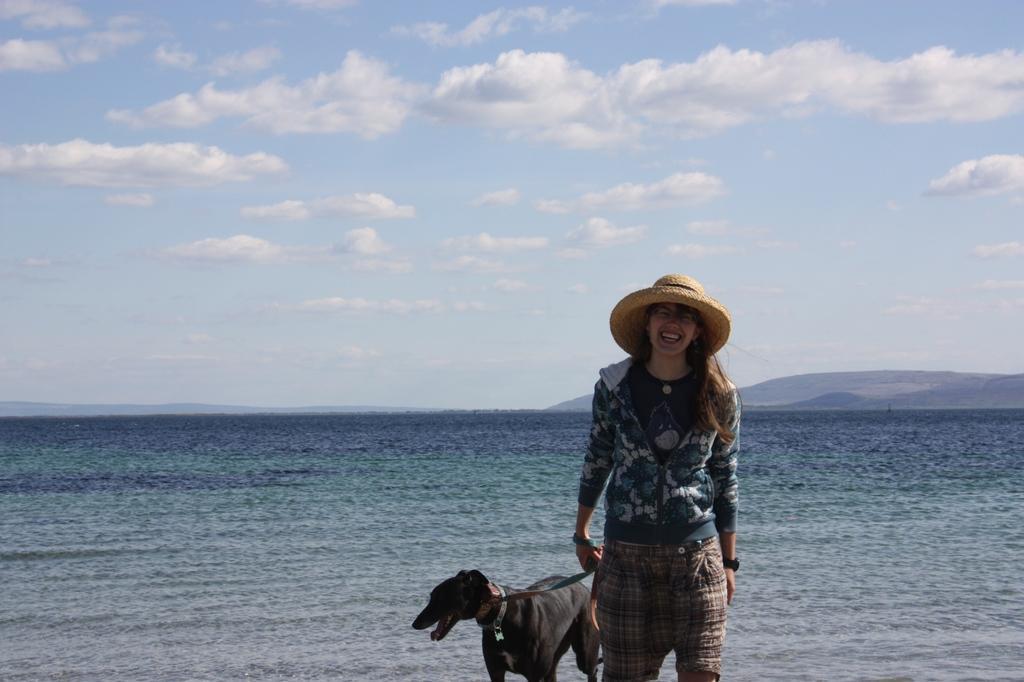In one or two sentences, can you explain what this image depicts? This is the outside view. In this image, we can see a woman. She hold a dog belt. There is a dog here beside her. The background, we can see a sea and sky with clouds. Here woman is wearing a hat. And she wear a t-shirt and jacket, short. Here right side, we can see some mountains. 